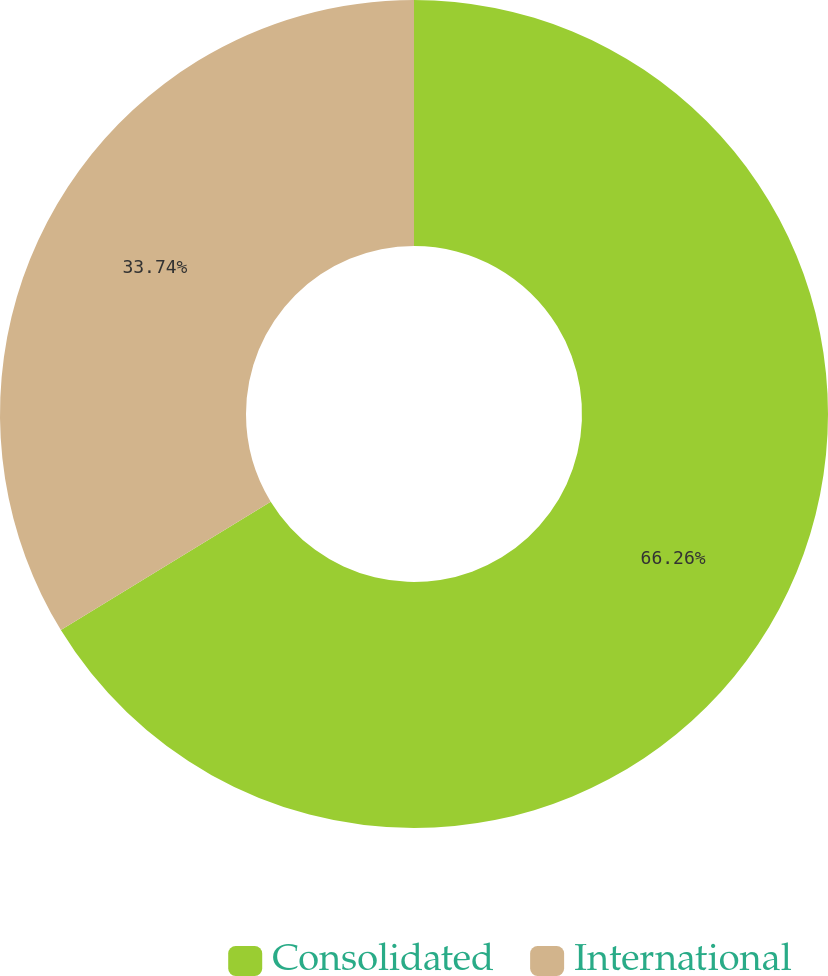Convert chart to OTSL. <chart><loc_0><loc_0><loc_500><loc_500><pie_chart><fcel>Consolidated<fcel>International<nl><fcel>66.26%<fcel>33.74%<nl></chart> 